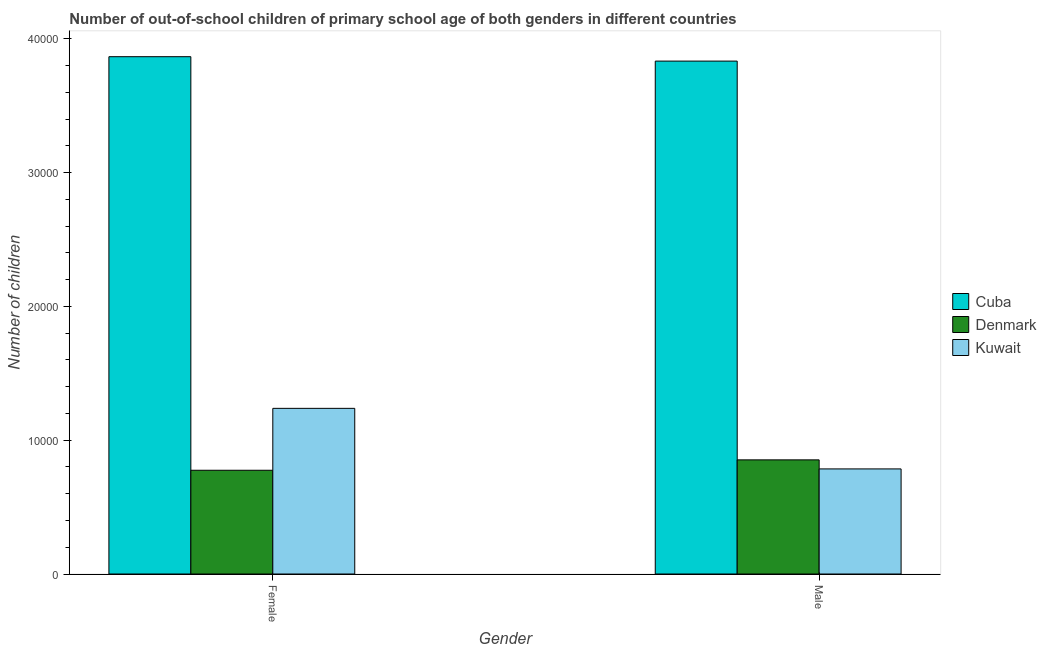How many different coloured bars are there?
Offer a very short reply. 3. How many groups of bars are there?
Your answer should be compact. 2. Are the number of bars per tick equal to the number of legend labels?
Offer a very short reply. Yes. How many bars are there on the 2nd tick from the right?
Provide a short and direct response. 3. What is the label of the 2nd group of bars from the left?
Your response must be concise. Male. What is the number of female out-of-school students in Kuwait?
Offer a terse response. 1.24e+04. Across all countries, what is the maximum number of male out-of-school students?
Keep it short and to the point. 3.83e+04. Across all countries, what is the minimum number of male out-of-school students?
Give a very brief answer. 7856. In which country was the number of male out-of-school students maximum?
Provide a short and direct response. Cuba. In which country was the number of female out-of-school students minimum?
Offer a terse response. Denmark. What is the total number of female out-of-school students in the graph?
Give a very brief answer. 5.88e+04. What is the difference between the number of male out-of-school students in Denmark and that in Cuba?
Give a very brief answer. -2.98e+04. What is the difference between the number of female out-of-school students in Cuba and the number of male out-of-school students in Kuwait?
Ensure brevity in your answer.  3.08e+04. What is the average number of male out-of-school students per country?
Make the answer very short. 1.82e+04. What is the difference between the number of male out-of-school students and number of female out-of-school students in Denmark?
Offer a terse response. 777. In how many countries, is the number of female out-of-school students greater than 24000 ?
Your response must be concise. 1. What is the ratio of the number of female out-of-school students in Cuba to that in Denmark?
Keep it short and to the point. 4.99. In how many countries, is the number of male out-of-school students greater than the average number of male out-of-school students taken over all countries?
Your answer should be compact. 1. What does the 3rd bar from the left in Female represents?
Provide a succinct answer. Kuwait. What does the 1st bar from the right in Male represents?
Provide a short and direct response. Kuwait. How many bars are there?
Offer a terse response. 6. Are all the bars in the graph horizontal?
Keep it short and to the point. No. How many countries are there in the graph?
Keep it short and to the point. 3. Are the values on the major ticks of Y-axis written in scientific E-notation?
Keep it short and to the point. No. Does the graph contain any zero values?
Your answer should be very brief. No. How many legend labels are there?
Your answer should be compact. 3. How are the legend labels stacked?
Make the answer very short. Vertical. What is the title of the graph?
Your response must be concise. Number of out-of-school children of primary school age of both genders in different countries. Does "Malta" appear as one of the legend labels in the graph?
Give a very brief answer. No. What is the label or title of the Y-axis?
Your answer should be very brief. Number of children. What is the Number of children of Cuba in Female?
Your answer should be compact. 3.87e+04. What is the Number of children of Denmark in Female?
Keep it short and to the point. 7756. What is the Number of children of Kuwait in Female?
Your response must be concise. 1.24e+04. What is the Number of children in Cuba in Male?
Provide a short and direct response. 3.83e+04. What is the Number of children of Denmark in Male?
Your response must be concise. 8533. What is the Number of children of Kuwait in Male?
Make the answer very short. 7856. Across all Gender, what is the maximum Number of children of Cuba?
Your answer should be compact. 3.87e+04. Across all Gender, what is the maximum Number of children in Denmark?
Offer a very short reply. 8533. Across all Gender, what is the maximum Number of children of Kuwait?
Ensure brevity in your answer.  1.24e+04. Across all Gender, what is the minimum Number of children in Cuba?
Provide a short and direct response. 3.83e+04. Across all Gender, what is the minimum Number of children of Denmark?
Keep it short and to the point. 7756. Across all Gender, what is the minimum Number of children of Kuwait?
Your answer should be very brief. 7856. What is the total Number of children of Cuba in the graph?
Your response must be concise. 7.70e+04. What is the total Number of children of Denmark in the graph?
Your answer should be compact. 1.63e+04. What is the total Number of children of Kuwait in the graph?
Your answer should be compact. 2.02e+04. What is the difference between the Number of children of Cuba in Female and that in Male?
Provide a succinct answer. 330. What is the difference between the Number of children in Denmark in Female and that in Male?
Your response must be concise. -777. What is the difference between the Number of children of Kuwait in Female and that in Male?
Keep it short and to the point. 4528. What is the difference between the Number of children in Cuba in Female and the Number of children in Denmark in Male?
Give a very brief answer. 3.01e+04. What is the difference between the Number of children of Cuba in Female and the Number of children of Kuwait in Male?
Provide a short and direct response. 3.08e+04. What is the difference between the Number of children in Denmark in Female and the Number of children in Kuwait in Male?
Your answer should be compact. -100. What is the average Number of children of Cuba per Gender?
Give a very brief answer. 3.85e+04. What is the average Number of children in Denmark per Gender?
Ensure brevity in your answer.  8144.5. What is the average Number of children of Kuwait per Gender?
Your response must be concise. 1.01e+04. What is the difference between the Number of children in Cuba and Number of children in Denmark in Female?
Give a very brief answer. 3.09e+04. What is the difference between the Number of children of Cuba and Number of children of Kuwait in Female?
Offer a terse response. 2.63e+04. What is the difference between the Number of children of Denmark and Number of children of Kuwait in Female?
Your response must be concise. -4628. What is the difference between the Number of children in Cuba and Number of children in Denmark in Male?
Give a very brief answer. 2.98e+04. What is the difference between the Number of children of Cuba and Number of children of Kuwait in Male?
Your answer should be compact. 3.05e+04. What is the difference between the Number of children in Denmark and Number of children in Kuwait in Male?
Ensure brevity in your answer.  677. What is the ratio of the Number of children of Cuba in Female to that in Male?
Your answer should be very brief. 1.01. What is the ratio of the Number of children of Denmark in Female to that in Male?
Provide a succinct answer. 0.91. What is the ratio of the Number of children in Kuwait in Female to that in Male?
Your response must be concise. 1.58. What is the difference between the highest and the second highest Number of children in Cuba?
Your answer should be compact. 330. What is the difference between the highest and the second highest Number of children in Denmark?
Provide a succinct answer. 777. What is the difference between the highest and the second highest Number of children of Kuwait?
Give a very brief answer. 4528. What is the difference between the highest and the lowest Number of children in Cuba?
Offer a terse response. 330. What is the difference between the highest and the lowest Number of children of Denmark?
Provide a short and direct response. 777. What is the difference between the highest and the lowest Number of children of Kuwait?
Your response must be concise. 4528. 